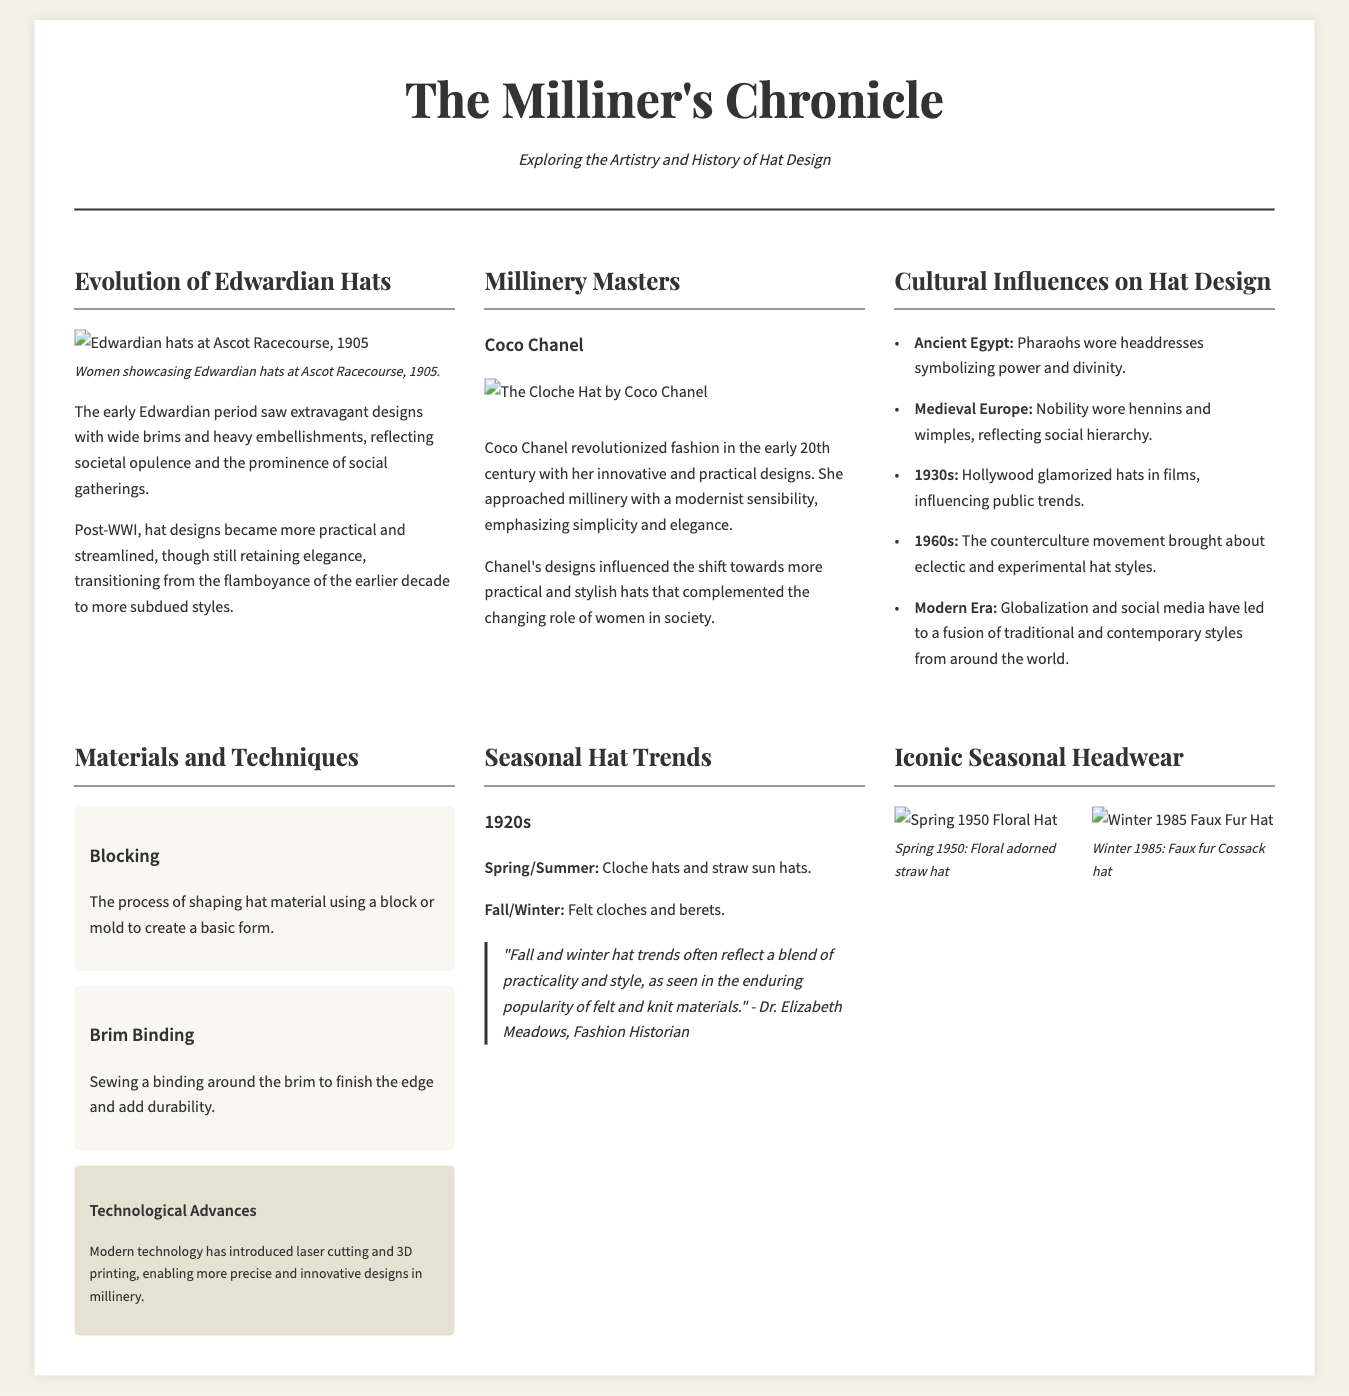What was the primary hat style of the early Edwardian period? The early Edwardian period was characterized by extravagant designs with wide brims and heavy embellishments.
Answer: wide brims Who is a prominent figure featured in the "Millinery Masters" section? The document mentions several influential designers, with Coco Chanel noted for her innovative designs.
Answer: Coco Chanel What technological advancement is noted in the "Materials and Techniques" section? Modern technology is discussed, highlighting advancements that have improved hat-making processes.
Answer: laser cutting and 3D printing Which decade's trends include cloche hats and straw sun hats for Spring/Summer? The document specifies seasonal trends for different decades, with cloche hats recognized for the 1920s.
Answer: 1920s What cultural influence is noted for the 1960s? The document reflects on the eclectic and experimental hat styles that emerged during this period.
Answer: counterculture movement What is the focal theme of the article "Cultural Influences on Hat Design"? This article discusses how various cultures and historical events have shaped hat fashion over time.
Answer: Cultural influences In what year did women showcase Edwardian hats at Ascot Racecourse, as depicted in the photograph? The document features a photograph from a specific event showcasing Edwardian hats, dated 1905.
Answer: 1905 What type of hat was highlighted as iconic in the Spring 1950 gallery image? The Spring 1950 gallery features a floral adorned straw hat as part of its representation of seasonal headwear.
Answer: floral adorned straw hat 